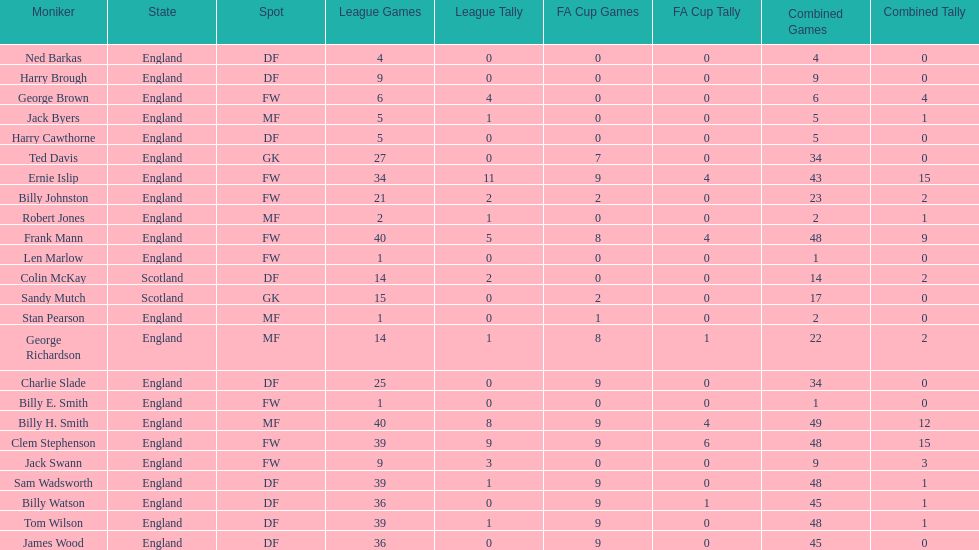Name the nation with the most appearances. England. 